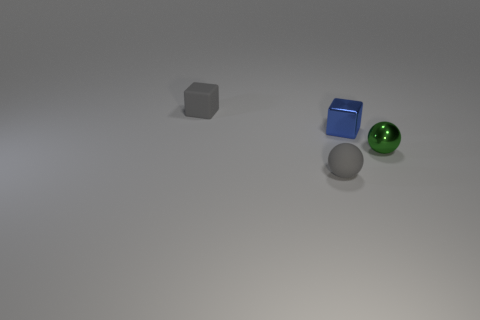Add 1 gray cubes. How many objects exist? 5 Subtract 0 blue balls. How many objects are left? 4 Subtract all matte cubes. Subtract all blue metal cubes. How many objects are left? 2 Add 4 gray rubber balls. How many gray rubber balls are left? 5 Add 4 small spheres. How many small spheres exist? 6 